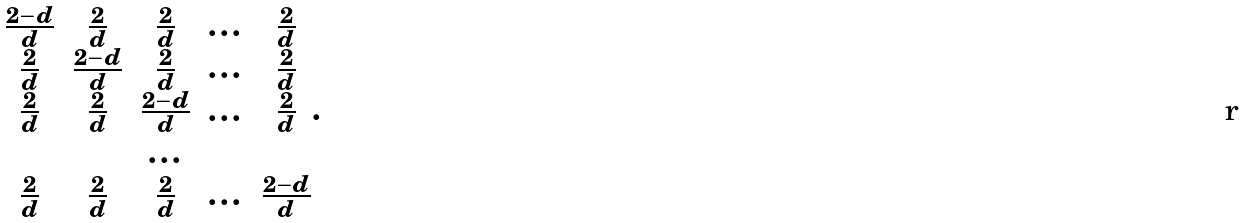<formula> <loc_0><loc_0><loc_500><loc_500>\begin{matrix} \frac { 2 - d } { d } & \frac { 2 } { d } & \frac { 2 } { d } & \dots & \frac { 2 } { d } \\ \frac { 2 } { d } & \frac { 2 - d } { d } & \frac { 2 } { d } & \dots & \frac { 2 } { d } \\ \frac { 2 } { d } & \frac { 2 } { d } & \frac { 2 - d } { d } & \dots & \frac { 2 } { d } \\ & & \dots & & \\ \frac { 2 } { d } & \frac { 2 } { d } & \frac { 2 } { d } & \dots & \frac { 2 - d } { d } \\ \end{matrix} .</formula> 